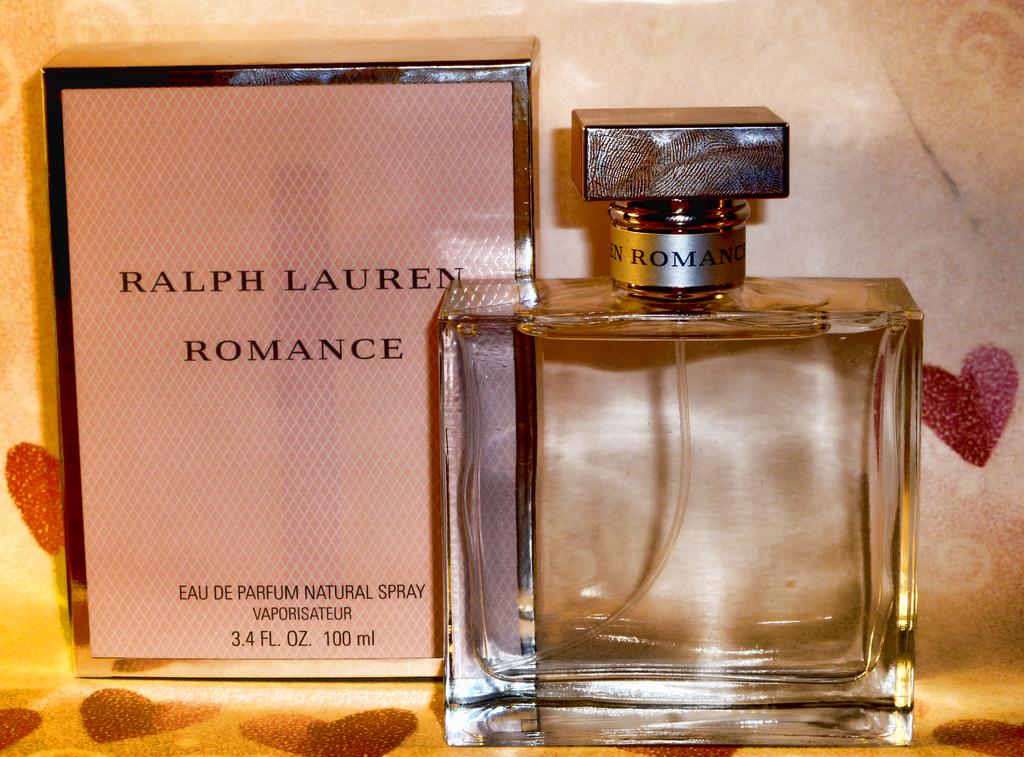Who makes the fragrance "romance"?
Offer a very short reply. Ralph lauren. How many ounces on the box?
Provide a succinct answer. 3.4. 